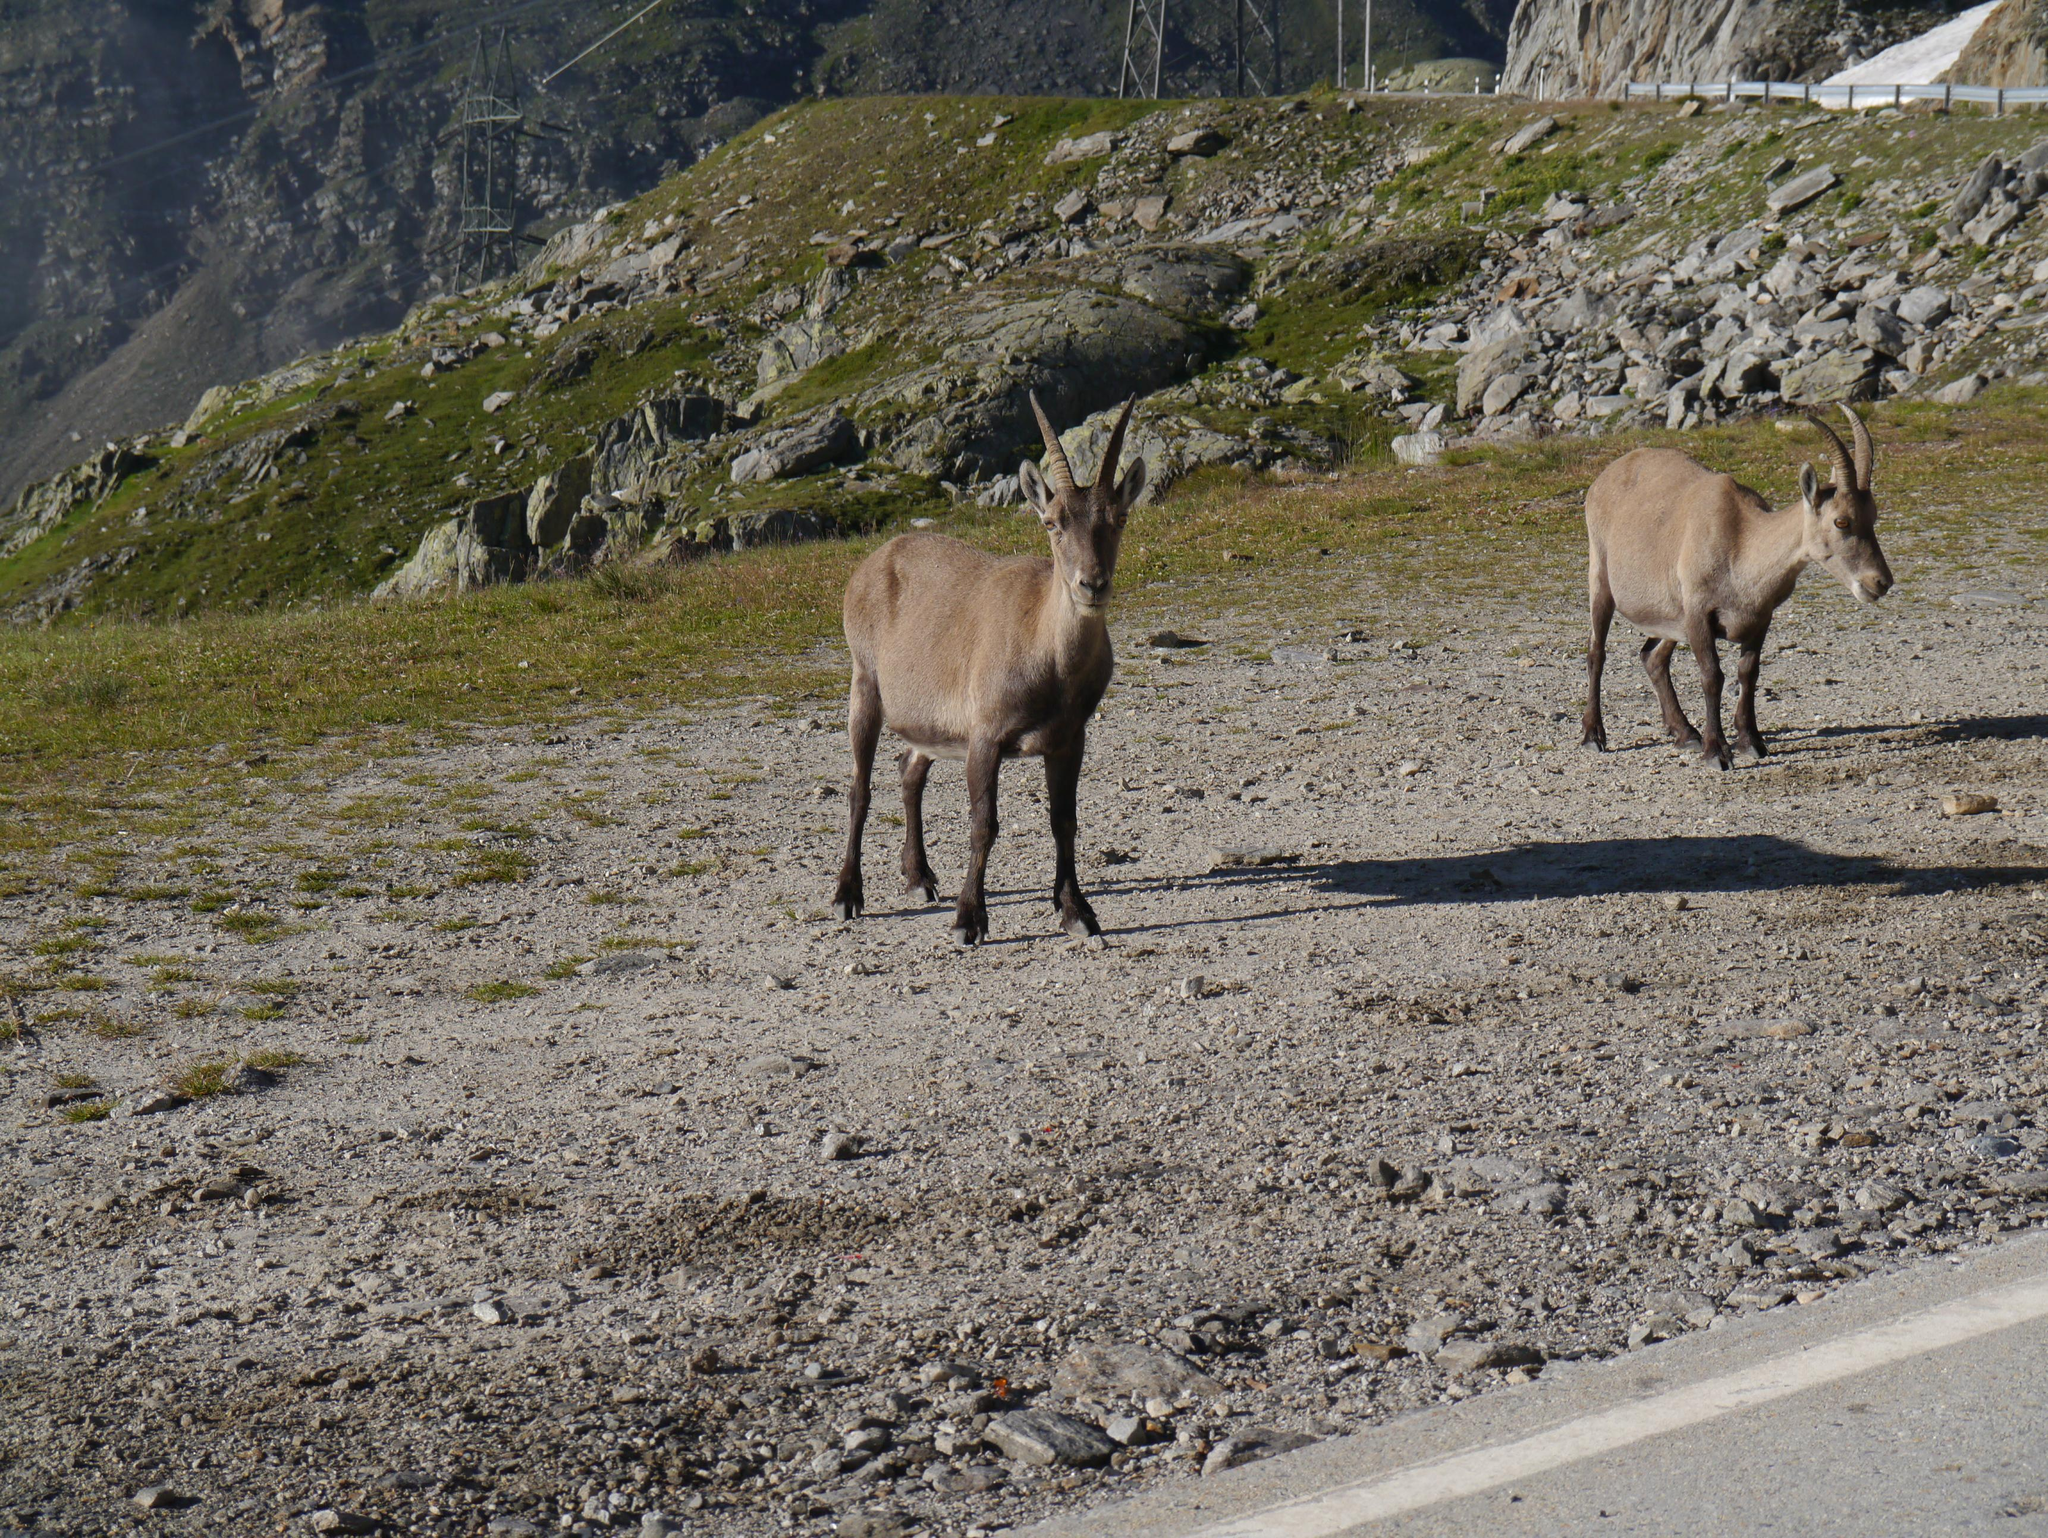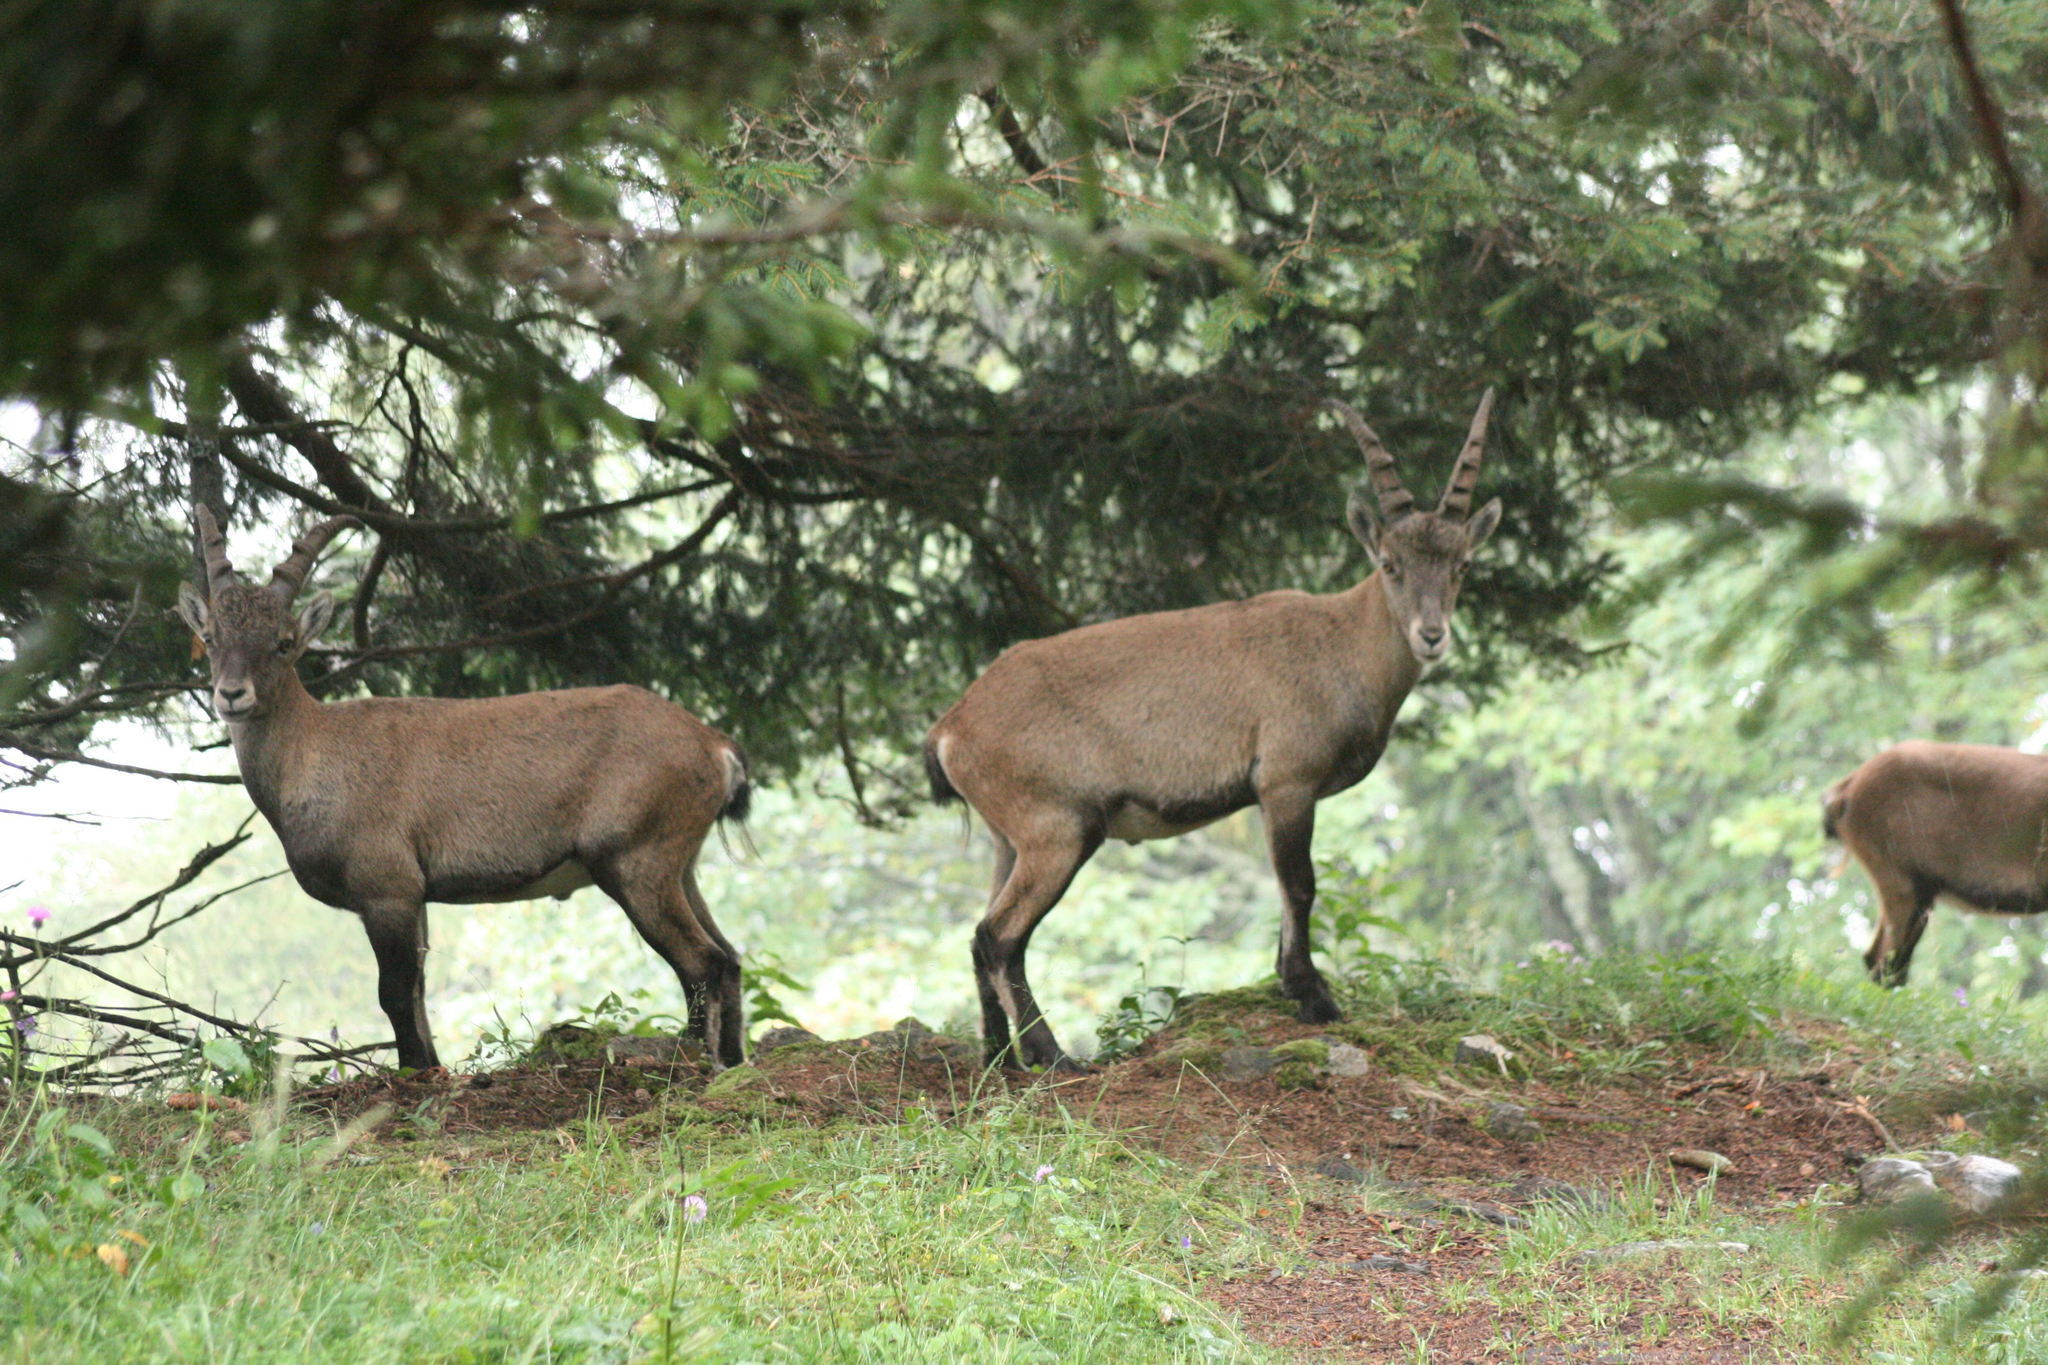The first image is the image on the left, the second image is the image on the right. Evaluate the accuracy of this statement regarding the images: "The left image shows two animals standing under a tree.". Is it true? Answer yes or no. No. The first image is the image on the left, the second image is the image on the right. For the images displayed, is the sentence "The right image includes at least twice the number of horned animals as the left image." factually correct? Answer yes or no. No. 